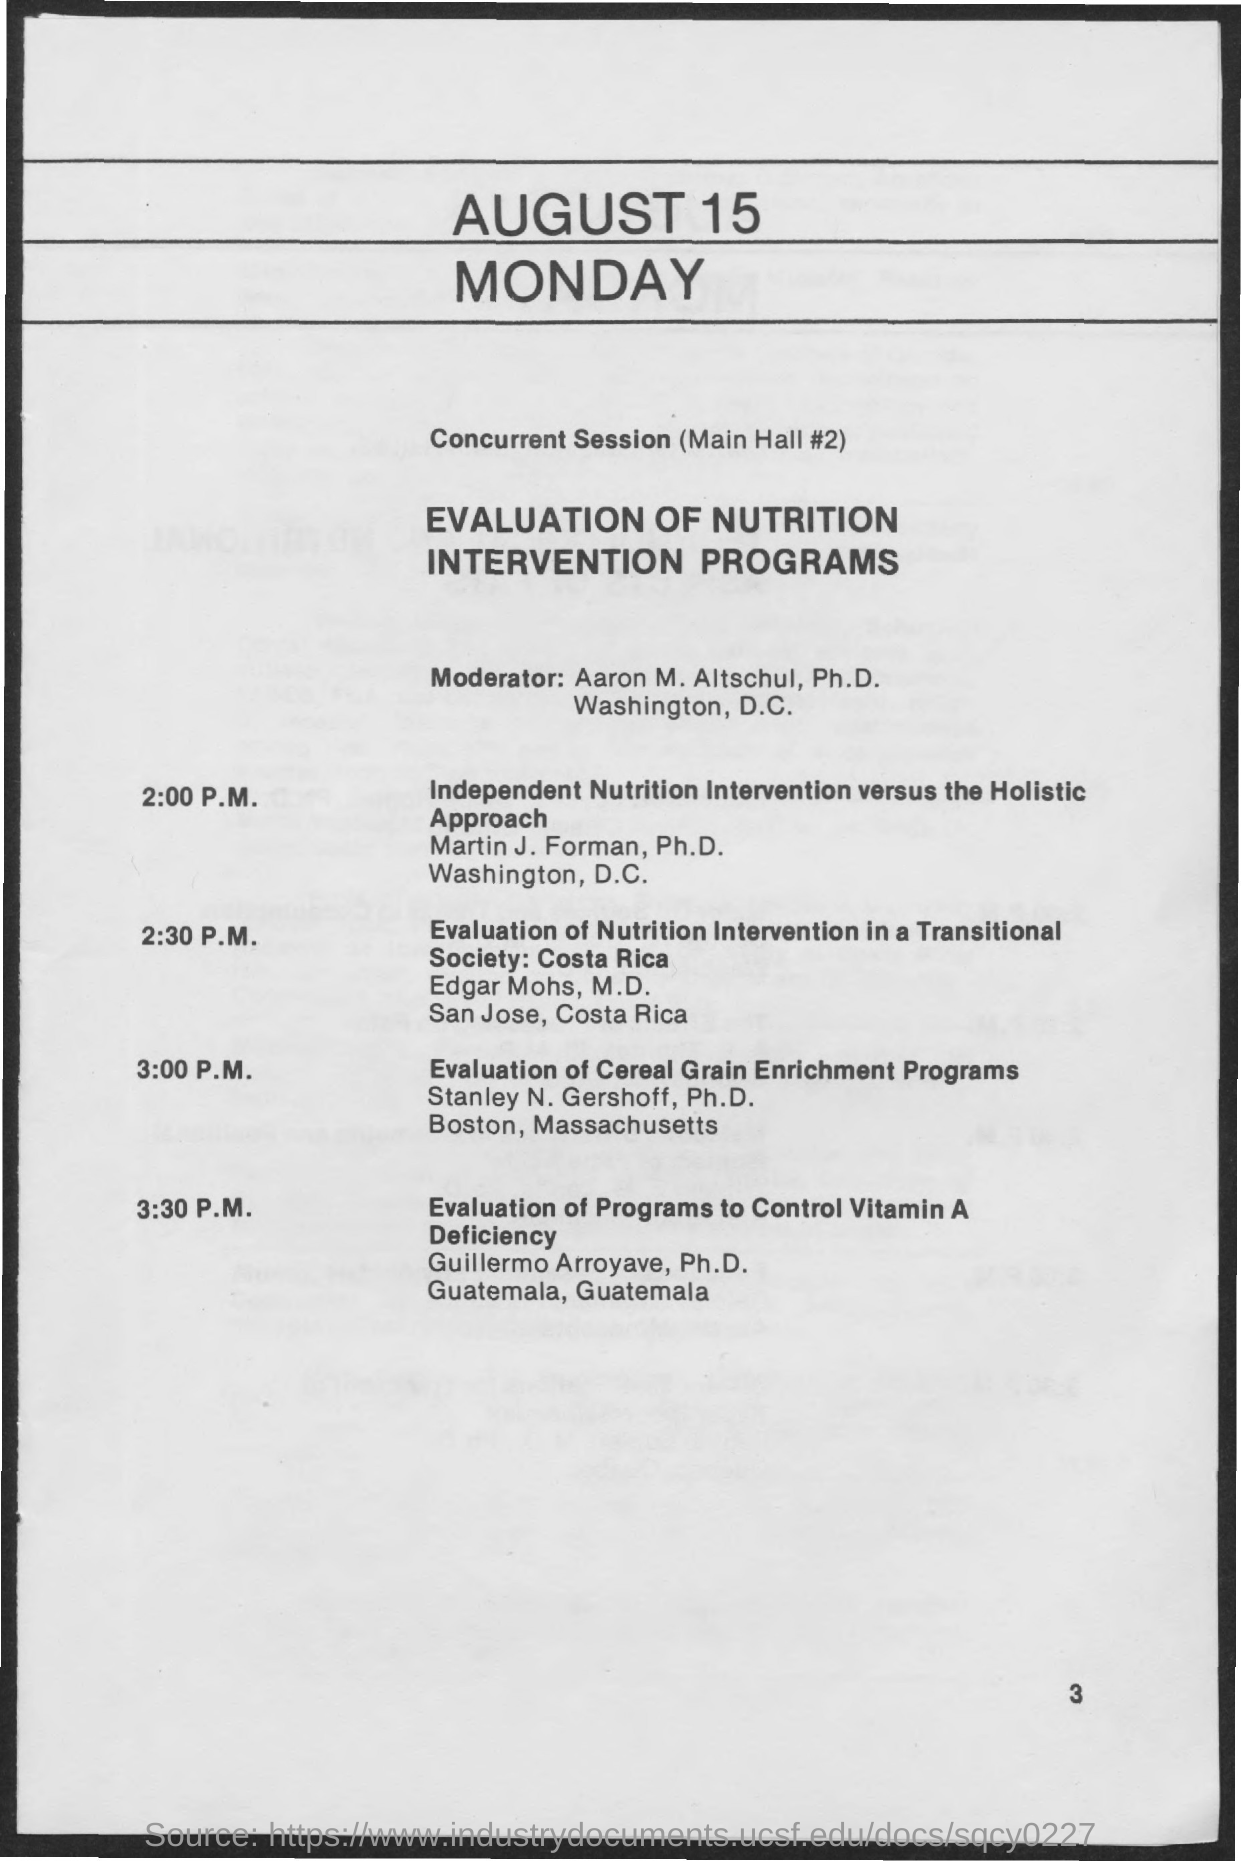What is this program on?
Make the answer very short. Evaluation of nutrition intervention programs. Who is the moderator of this program?
Offer a very short reply. Aaron M.Altschul,Ph.D. What is the session at 2:00 P.M.?
Ensure brevity in your answer.  Independent nutrition intervention versus the holistic approach. What is the session at 2:30 P.M.?
Give a very brief answer. Evaluation of Nutrition Intervention in a Transitional Society:Costa Rica. What is the session at 3:00 P.M.?
Make the answer very short. Evaluation of Cereal Grain Enrichment Programs. What is the session at 3:30 P.M.?
Keep it short and to the point. Evaluation of Programs to Control Vitamin A Deficiency. Who handles 3:30 P.M. session?
Keep it short and to the point. Guillermo arroyave, ph.d. Who handles 3:00 P.M. session?
Your response must be concise. Stanley n. gershoff. Who handles 2:30 P.M. session?
Provide a succinct answer. Edgar mohs. Who handles 2:00 P.M. session?
Give a very brief answer. Martin J .Forman, Ph.D. 